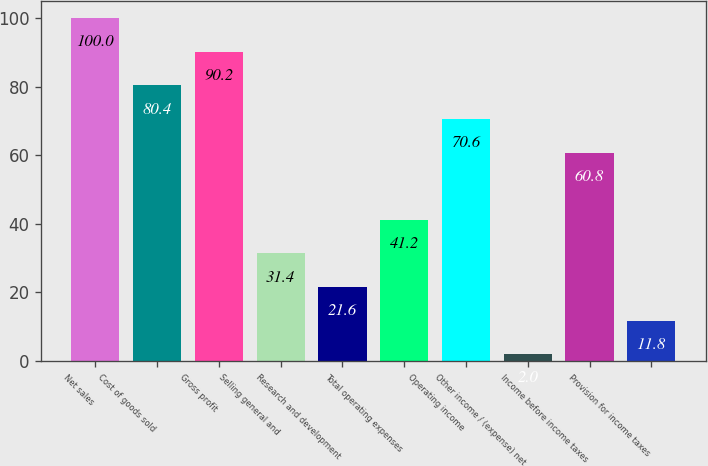Convert chart to OTSL. <chart><loc_0><loc_0><loc_500><loc_500><bar_chart><fcel>Net sales<fcel>Cost of goods sold<fcel>Gross profit<fcel>Selling general and<fcel>Research and development<fcel>Total operating expenses<fcel>Operating income<fcel>Other income / (expense) net<fcel>Income before income taxes<fcel>Provision for income taxes<nl><fcel>100<fcel>80.4<fcel>90.2<fcel>31.4<fcel>21.6<fcel>41.2<fcel>70.6<fcel>2<fcel>60.8<fcel>11.8<nl></chart> 